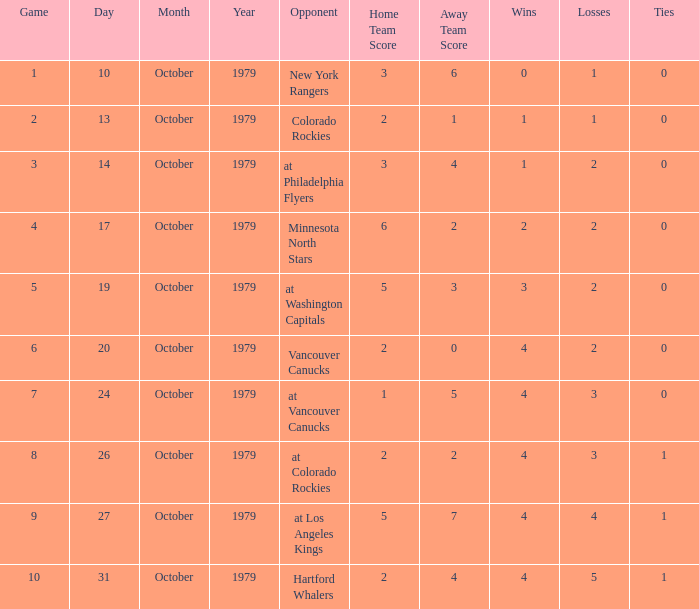What is the score for the opponent Vancouver Canucks? 2 - 0. 